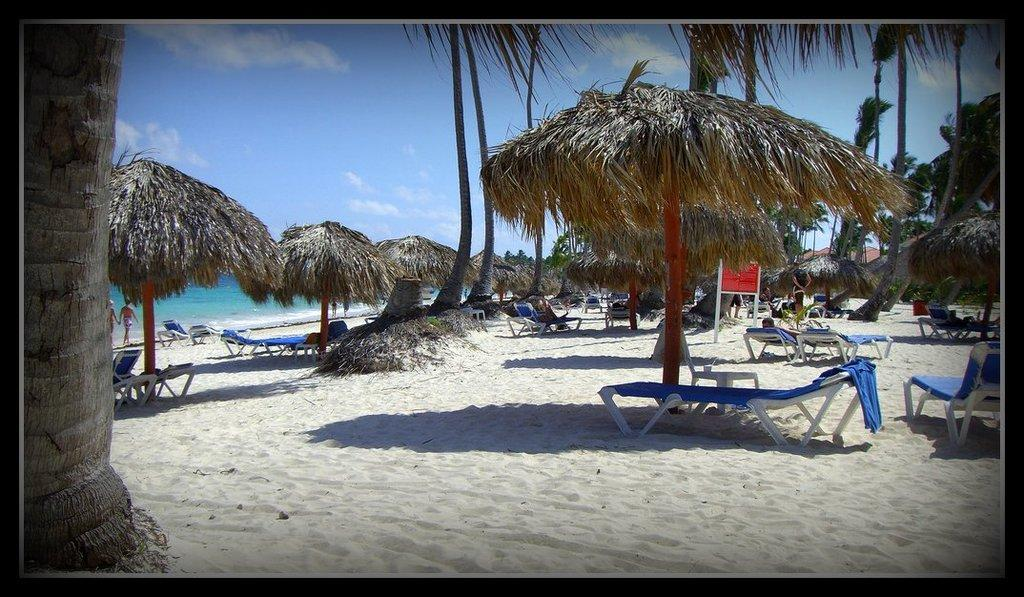What type of location is depicted in the image? The image depicts a beach scene. What type of structures can be seen in the image? There are single pole huts in the image. What type of furniture is present in the image? Chairs are present in the image. Are there any people in the image? Yes, there are people in the image. What is the color of the board visible in the image? The board is red in the image. What are the people wearing in the image? The people are wearing blue clothes in the image. What is the weather like in the image? The sky is cloudy in the image. What type of cushion is being used by the judge during the feast in the image? There is no judge or feast present in the image. The image depicts a beach scene with people wearing blue clothes and a red board. 